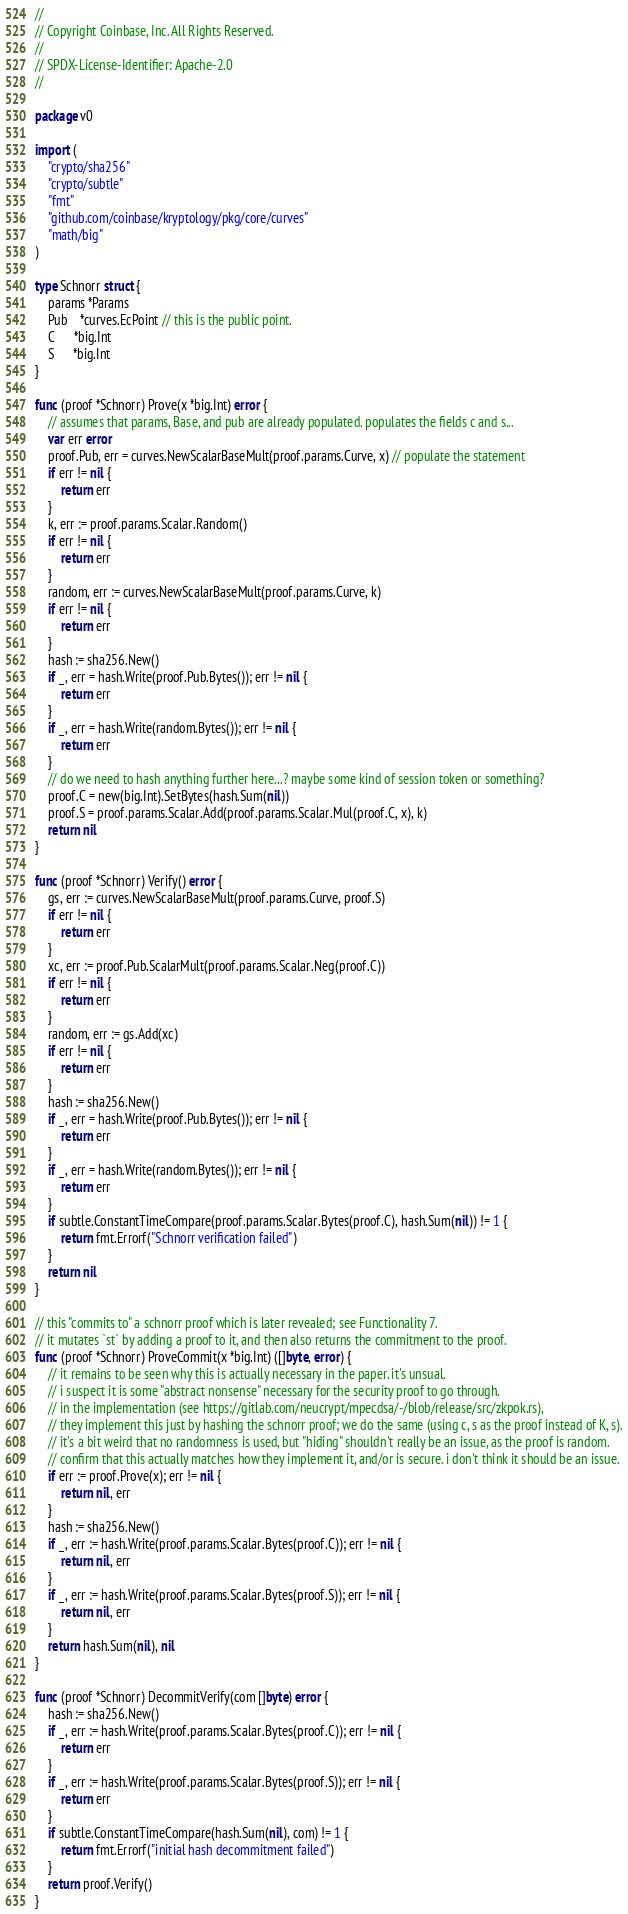Convert code to text. <code><loc_0><loc_0><loc_500><loc_500><_Go_>//
// Copyright Coinbase, Inc. All Rights Reserved.
//
// SPDX-License-Identifier: Apache-2.0
//

package v0

import (
	"crypto/sha256"
	"crypto/subtle"
	"fmt"
	"github.com/coinbase/kryptology/pkg/core/curves"
	"math/big"
)

type Schnorr struct {
	params *Params
	Pub    *curves.EcPoint // this is the public point.
	C      *big.Int
	S      *big.Int
}

func (proof *Schnorr) Prove(x *big.Int) error {
	// assumes that params, Base, and pub are already populated. populates the fields c and s...
	var err error
	proof.Pub, err = curves.NewScalarBaseMult(proof.params.Curve, x) // populate the statement
	if err != nil {
		return err
	}
	k, err := proof.params.Scalar.Random()
	if err != nil {
		return err
	}
	random, err := curves.NewScalarBaseMult(proof.params.Curve, k)
	if err != nil {
		return err
	}
	hash := sha256.New()
	if _, err = hash.Write(proof.Pub.Bytes()); err != nil {
		return err
	}
	if _, err = hash.Write(random.Bytes()); err != nil {
		return err
	}
	// do we need to hash anything further here...? maybe some kind of session token or something?
	proof.C = new(big.Int).SetBytes(hash.Sum(nil))
	proof.S = proof.params.Scalar.Add(proof.params.Scalar.Mul(proof.C, x), k)
	return nil
}

func (proof *Schnorr) Verify() error {
	gs, err := curves.NewScalarBaseMult(proof.params.Curve, proof.S)
	if err != nil {
		return err
	}
	xc, err := proof.Pub.ScalarMult(proof.params.Scalar.Neg(proof.C))
	if err != nil {
		return err
	}
	random, err := gs.Add(xc)
	if err != nil {
		return err
	}
	hash := sha256.New()
	if _, err = hash.Write(proof.Pub.Bytes()); err != nil {
		return err
	}
	if _, err = hash.Write(random.Bytes()); err != nil {
		return err
	}
	if subtle.ConstantTimeCompare(proof.params.Scalar.Bytes(proof.C), hash.Sum(nil)) != 1 {
		return fmt.Errorf("Schnorr verification failed")
	}
	return nil
}

// this "commits to" a schnorr proof which is later revealed; see Functionality 7.
// it mutates `st` by adding a proof to it, and then also returns the commitment to the proof.
func (proof *Schnorr) ProveCommit(x *big.Int) ([]byte, error) {
	// it remains to be seen why this is actually necessary in the paper. it's unsual.
	// i suspect it is some "abstract nonsense" necessary for the security proof to go through.
	// in the implementation (see https://gitlab.com/neucrypt/mpecdsa/-/blob/release/src/zkpok.rs),
	// they implement this just by hashing the schnorr proof; we do the same (using c, s as the proof instead of K, s).
	// it's a bit weird that no randomness is used, but "hiding" shouldn't really be an issue, as the proof is random.
	// confirm that this actually matches how they implement it, and/or is secure. i don't think it should be an issue.
	if err := proof.Prove(x); err != nil {
		return nil, err
	}
	hash := sha256.New()
	if _, err := hash.Write(proof.params.Scalar.Bytes(proof.C)); err != nil {
		return nil, err
	}
	if _, err := hash.Write(proof.params.Scalar.Bytes(proof.S)); err != nil {
		return nil, err
	}
	return hash.Sum(nil), nil
}

func (proof *Schnorr) DecommitVerify(com []byte) error {
	hash := sha256.New()
	if _, err := hash.Write(proof.params.Scalar.Bytes(proof.C)); err != nil {
		return err
	}
	if _, err := hash.Write(proof.params.Scalar.Bytes(proof.S)); err != nil {
		return err
	}
	if subtle.ConstantTimeCompare(hash.Sum(nil), com) != 1 {
		return fmt.Errorf("initial hash decommitment failed")
	}
	return proof.Verify()
}
</code> 